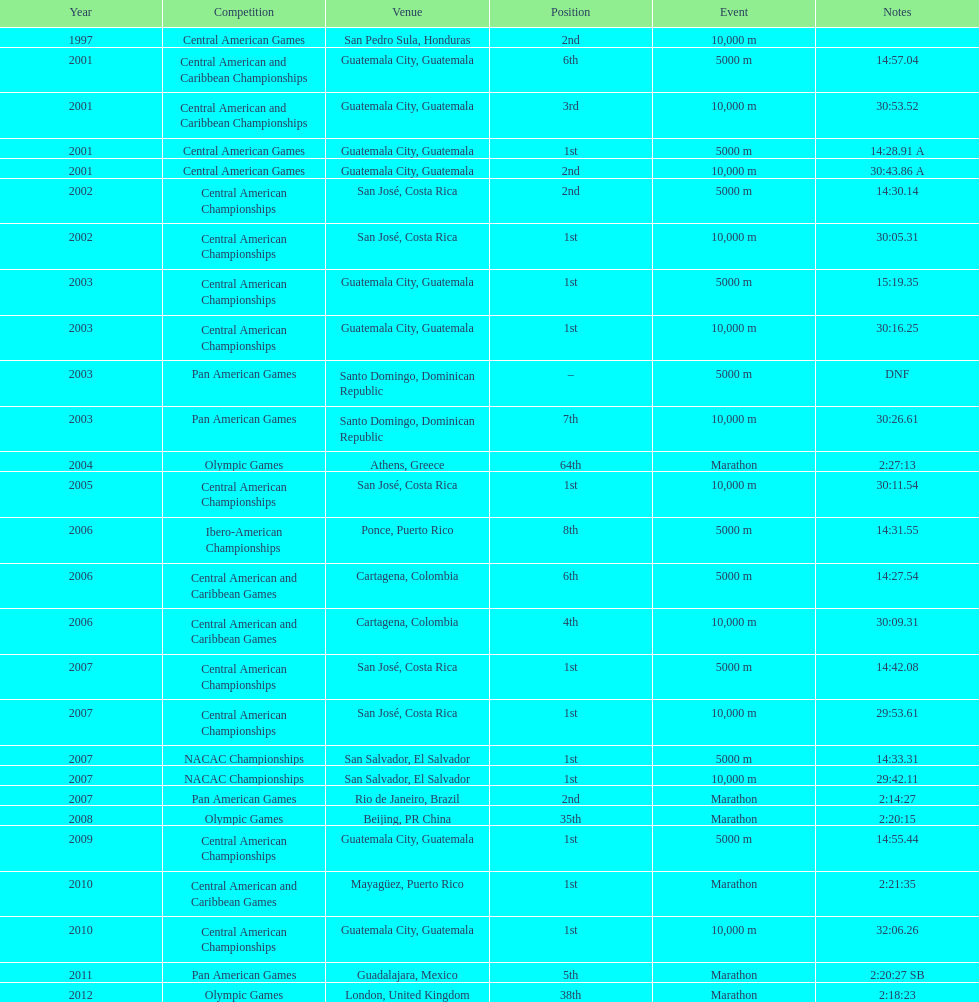How many times has this athlete not finished in a competition? 1. 